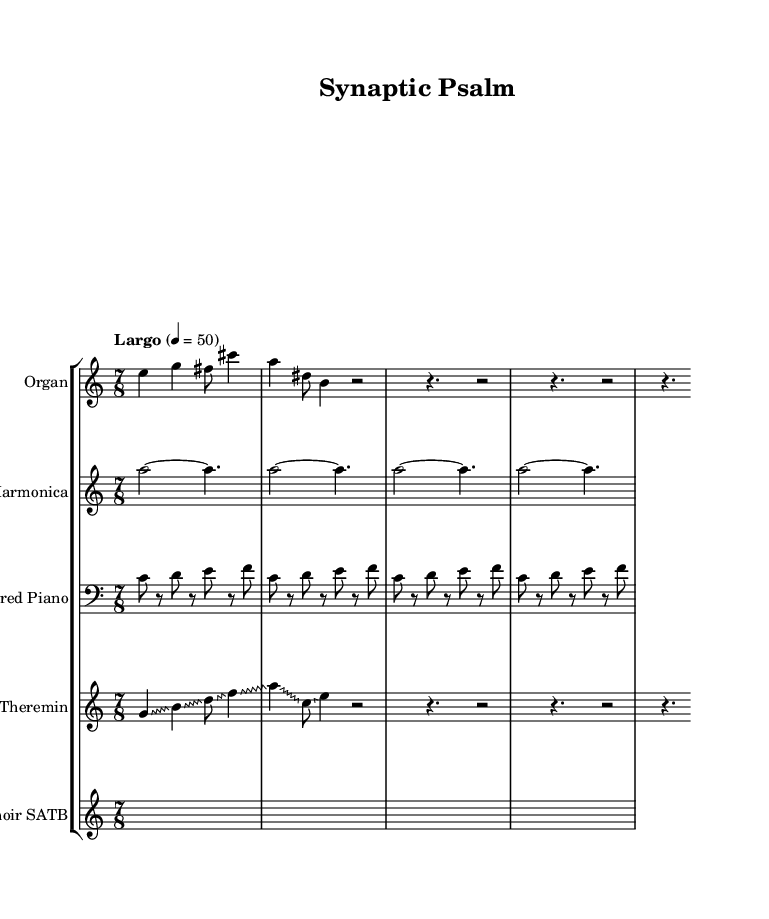What is the time signature of this music? The time signature is found at the beginning of the score. It is written as 7/8, indicating seven beats in each measure with an eighth note receiving one beat.
Answer: 7/8 What is the tempo marking for this composition? The tempo marking is indicated in the score as "Largo," which typically suggests a slow and broad tempo. The metronome marking given is 4 = 50, meaning there are 50 beats per minute.
Answer: Largo, 4 = 50 How many different instruments are notated in this piece? By examining the score, you see that there are five distinct staves each labeled for a different instrument: Organ, Glass Harmonica, Prepared Piano, Theremin, and Choir SATB. Therefore, there are five instruments.
Answer: 5 What unique performance technique is used by the Theremin? The score for the Theremin shows a slur-like ornamentation that is labeled as "glissando," which means the performer should slide smoothly from one note to another rather than playing them separately. This is a distinctive characteristic of the Theremin.
Answer: Glissando Which voice type is represented in the Choir section? Looking at the score notation for the choir, it indicates SATB, which stands for Soprano, Alto, Tenor, and Bass. This signifies all four voice types are represented within the choir section.
Answer: SATB How does the Glass Harmonica voice differ from the Organ voice in this piece? The Organ voice has a varied rhythmic pattern with articulated notes while the Glass Harmonica voice consists of sustained notes indicated by ties and rests, emphasizing a fluid and ethereal quality. The comparison highlights the contrasting stylistic approaches of each instrument.
Answer: Sustained vs. articulated 